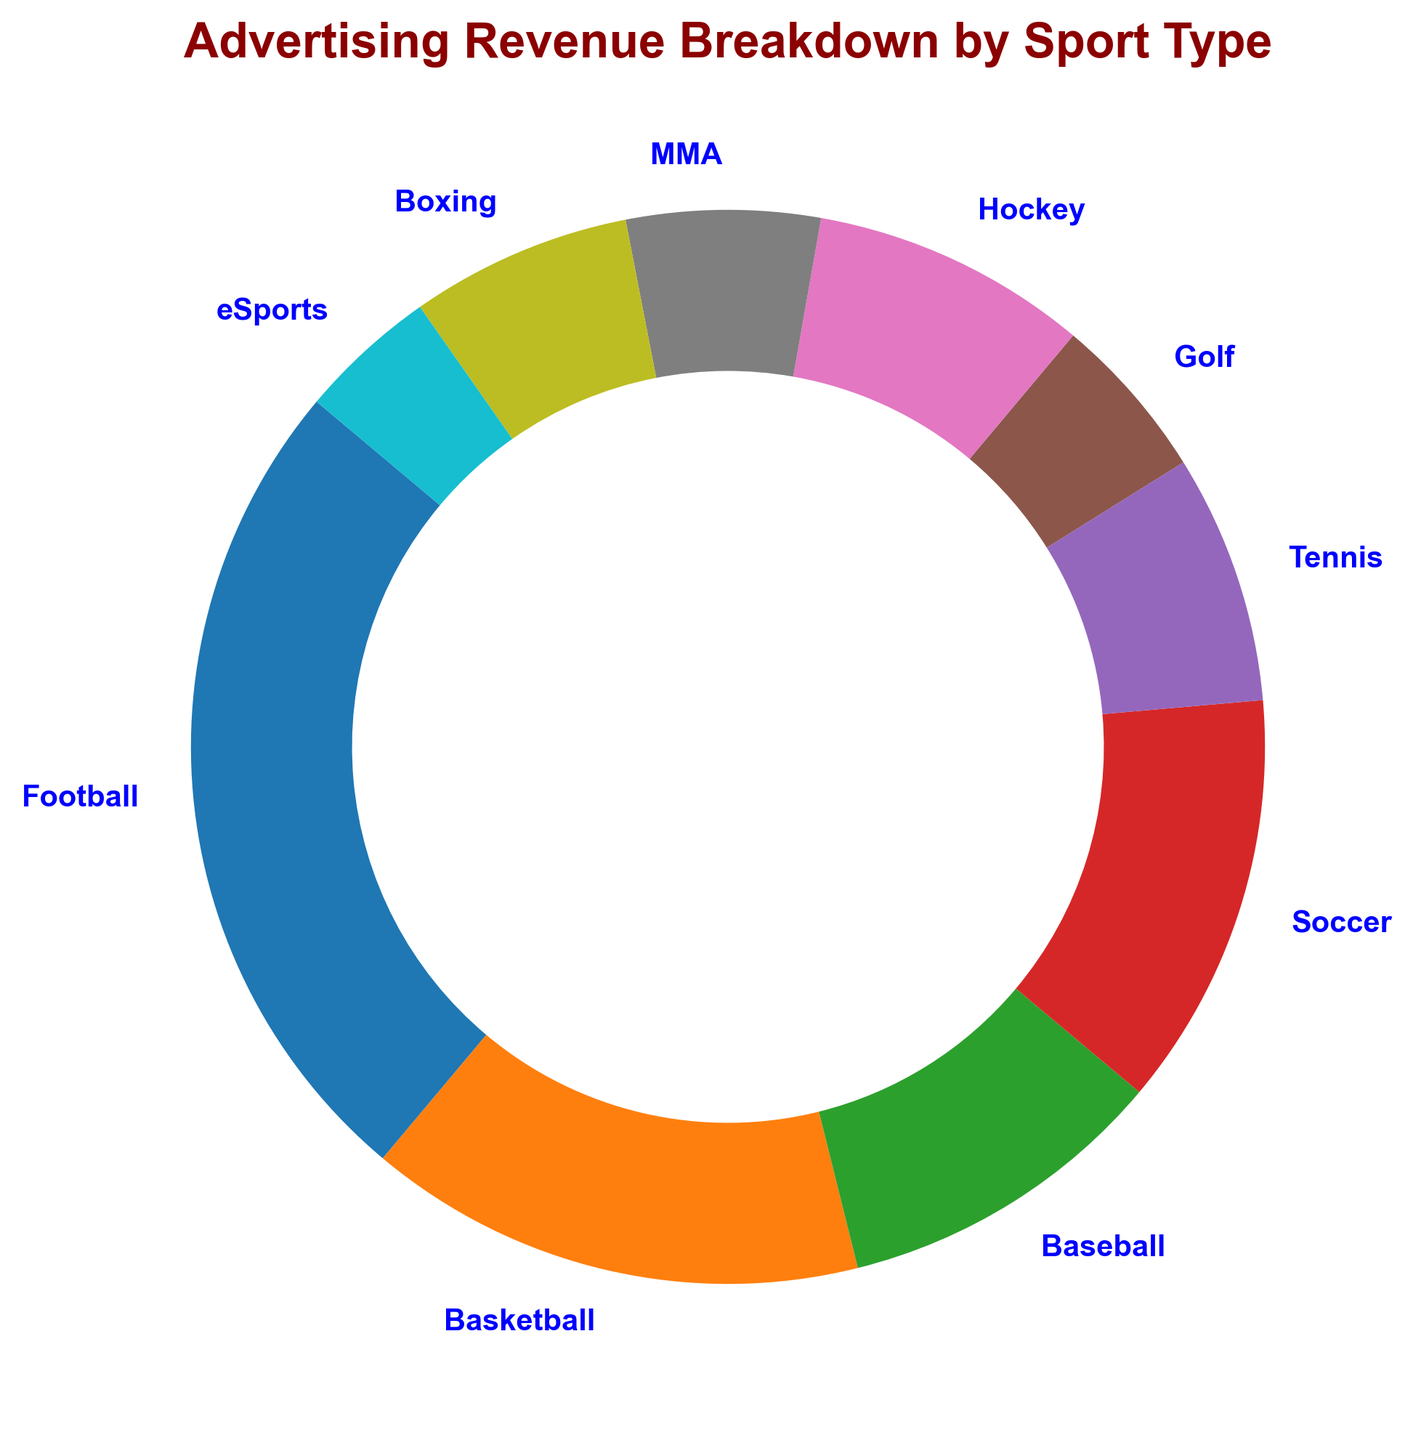What sport type generates the highest advertising revenue? By looking at the size of the wedges in the ring chart and the percentage labels, we can identify which sport type has the largest wedge. The biggest wedge represents Football.
Answer: Football Which sport type has a smaller advertising revenue share than Tennis but larger than eSports? By comparing the percentage shares in the ring chart, we see that Tennis has a larger share than Golf, and Golf has a larger share than eSports.
Answer: Golf What is the total advertising revenue for sports that generate more than 10% each? Football and Basketball are the sports that generate more than 10% each. The revenues are 150 million for Football and 90 million for Basketball. Total = 150 + 90 = 240 million.
Answer: 240 million How does advertising revenue from Baseball compare to that of Soccer? By comparing the percentage labels and the size of the wedges, Soccer generates more advertising revenue (75 million) than Baseball (60 million).
Answer: Soccer If you combine the advertising revenues of MMA, Boxing, and eSports, what is their total share percentage? The percentage shares for MMA, Boxing, and eSports are summed. MMA is 5.3%, Boxing is 6.4%, and eSports is 4.3%. Total = 5.3 + 6.4 + 4.3 = 16.0%.
Answer: 16.0% Which sport type contributes around the same advertising revenue as Golf and Hockey combined? Adding the revenues for Golf (30 million) and Hockey (50 million), we get 80 million. Soccer generates a similar amount with 75 million in advertising revenue.
Answer: Soccer What percentage of total advertising revenue do Tennis and Boxing together contribute? The percentage shares for Tennis (45 million) and Boxing (40 million) together = 8.0% + 7.1% = 15.1%.
Answer: 15.1% Which sport types together form less than 20% of the total advertising revenue? Adding the percentages of the sports with the smaller wedges, together they need to form less than 20%. This includes Golf (5.3%), Hockey (8.8%), MMA (6.1%), Boxing (7.1%), and eSports (4.3%).: 5.3 + 8.8 + 6.1 + 7.1 + 4.3 = 31.6%, so these set of smaller wedges belong to another combination check. The correct combination is the smaller sports Tennis (6.4%), Golf (4.3%) MMA (5.3%), and eSports(3.7%). Sum is: 6.4 + 5.3 + 4.3 + 3.7 = 19.7%.
Answer: Tennis, Golf, MMA, eSports 